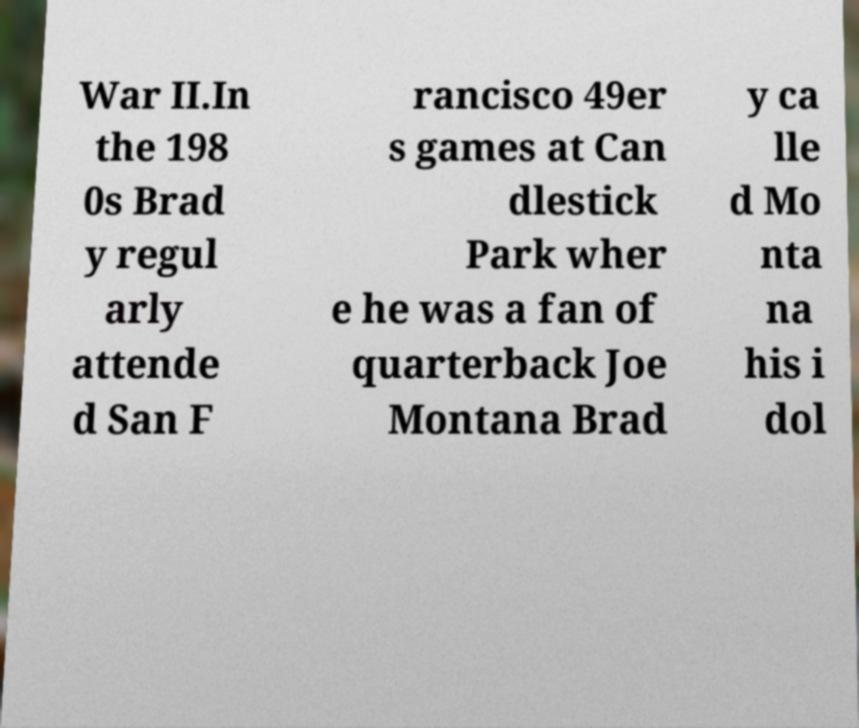Can you accurately transcribe the text from the provided image for me? War II.In the 198 0s Brad y regul arly attende d San F rancisco 49er s games at Can dlestick Park wher e he was a fan of quarterback Joe Montana Brad y ca lle d Mo nta na his i dol 